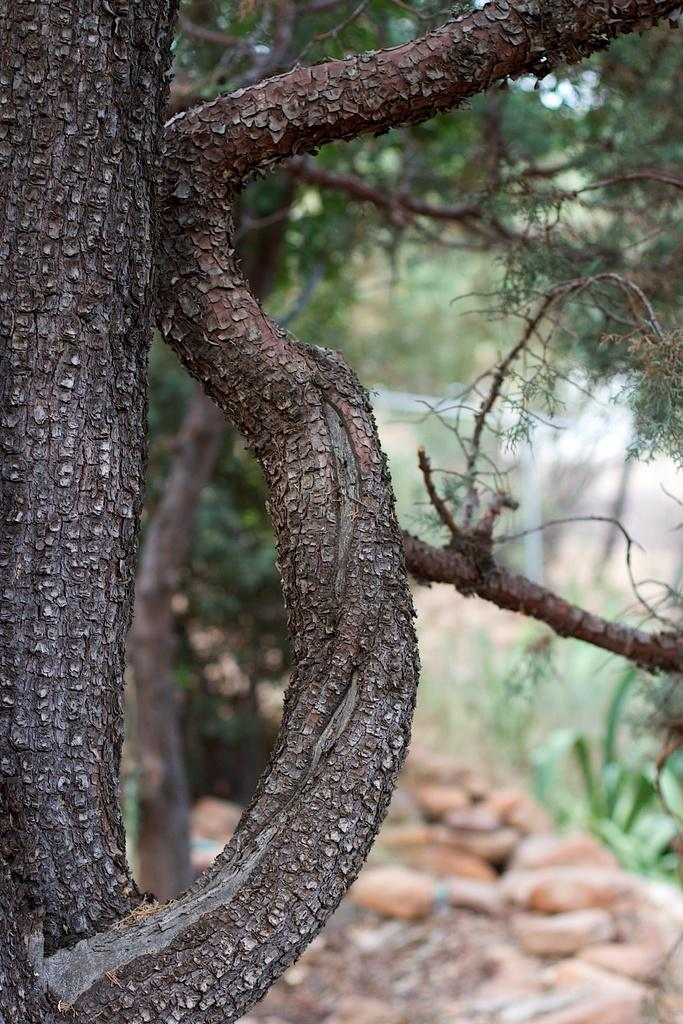What is the main subject of the image? The main subject of the image is a tree, including its trunk and branches. Are there any other objects or features in the image? Yes, there are stones visible in the image. How would you describe the background of the image? The background of the image is blurry. How many laborers are working on the tree in the image? There are no laborers present in the image; it only features a tree and stones. What type of bead can be seen hanging from the tree branches? There are no beads visible in the image; it only features a tree and stones. 